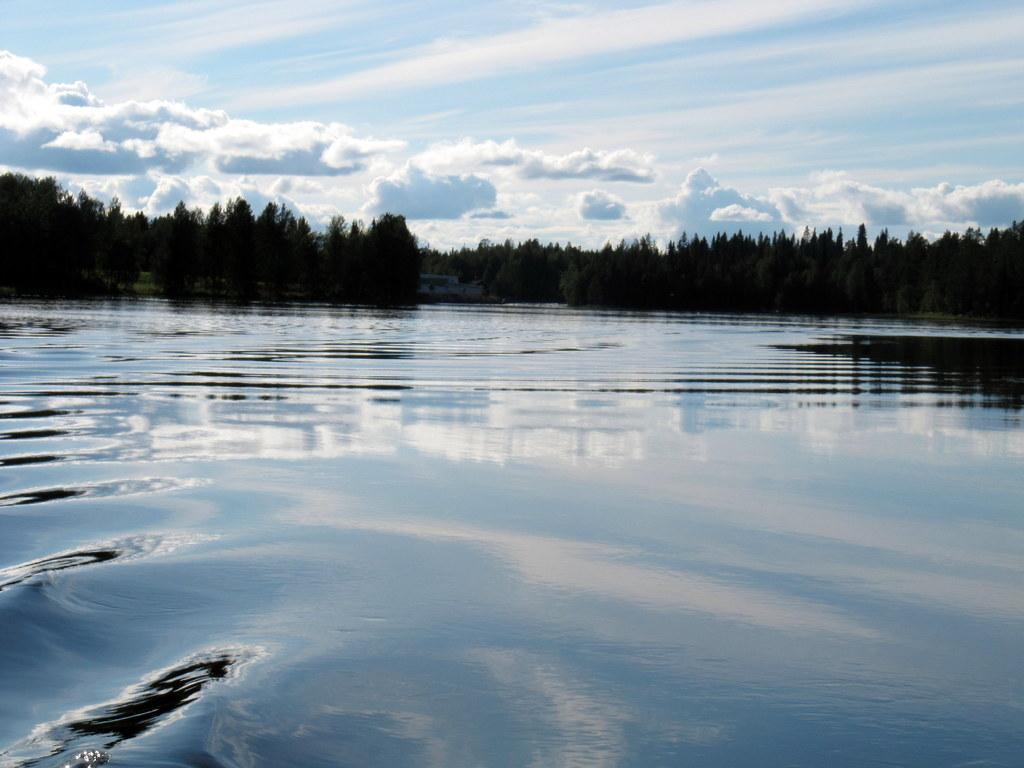Describe this image in one or two sentences. This image consists of water. There are trees in the middle. There is sky at the top. There are clouds in the middle. 